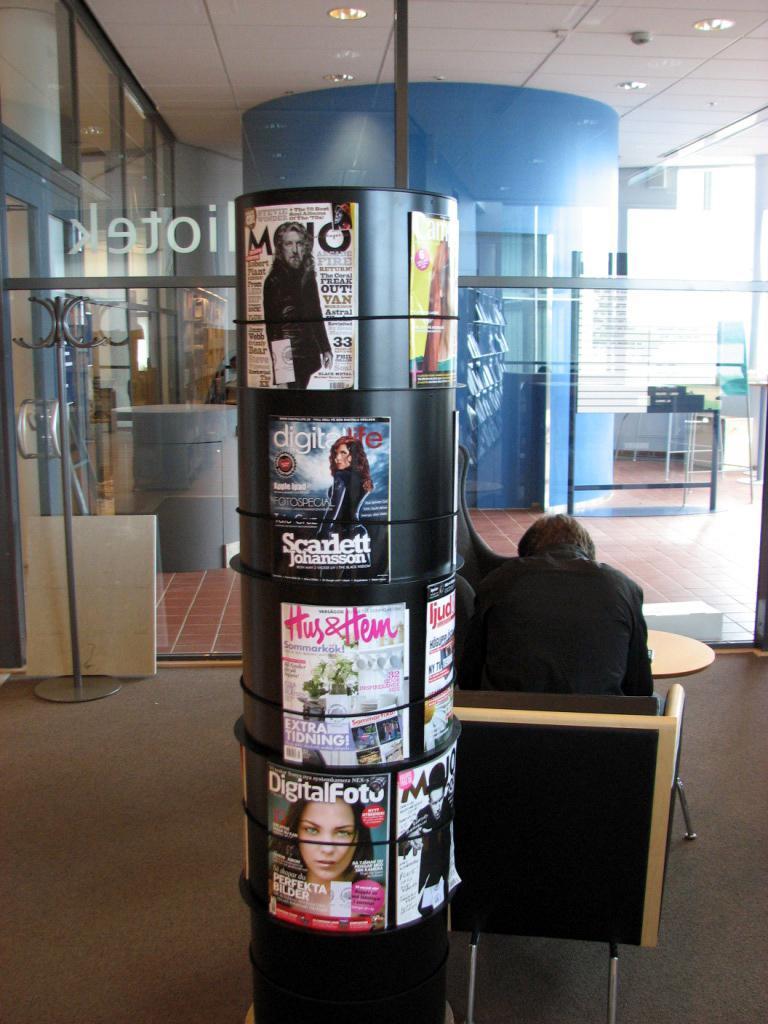How would you summarize this image in a sentence or two? In this image there is a board, on that board there are magazines, beside the board there is a man sitting on a chair, in the background there is a glass wall, at the top there is a ceiling and there are lights. 